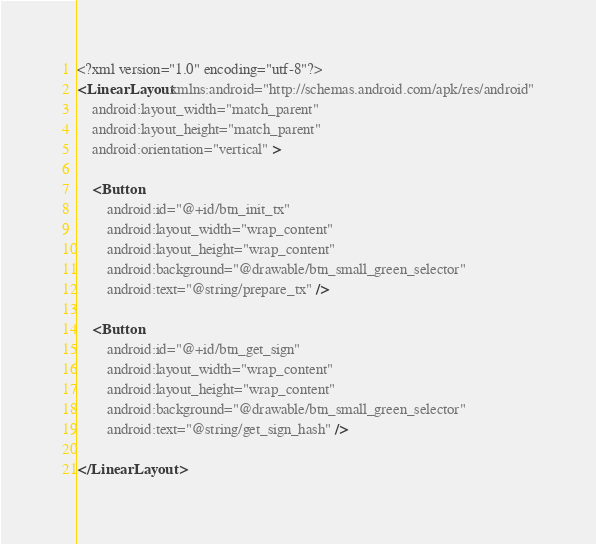<code> <loc_0><loc_0><loc_500><loc_500><_XML_><?xml version="1.0" encoding="utf-8"?>
<LinearLayout xmlns:android="http://schemas.android.com/apk/res/android"
    android:layout_width="match_parent"
    android:layout_height="match_parent"
    android:orientation="vertical" >

    <Button
        android:id="@+id/btn_init_tx"
        android:layout_width="wrap_content"
        android:layout_height="wrap_content"
        android:background="@drawable/btn_small_green_selector"
        android:text="@string/prepare_tx" />

    <Button
        android:id="@+id/btn_get_sign"
        android:layout_width="wrap_content"
        android:layout_height="wrap_content"
        android:background="@drawable/btn_small_green_selector"
        android:text="@string/get_sign_hash" />

</LinearLayout>
</code> 